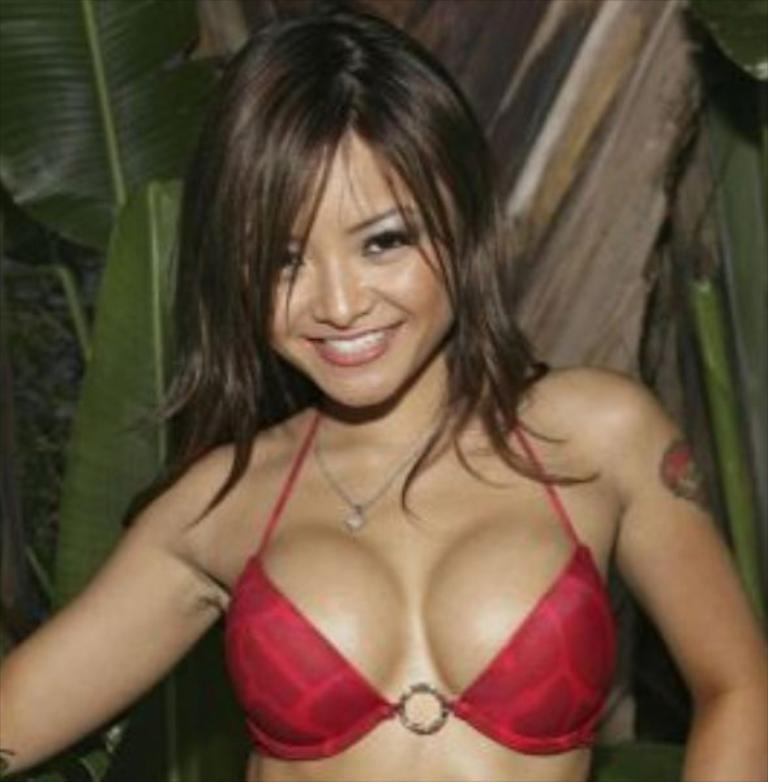What is the main subject of the image? There is a girl standing in the middle of the image. What can be seen in the background of the image? There are leaves visible in the background of the image. What type of map is the girl holding in the image? There is no map present in the image; the girl is not holding anything. 